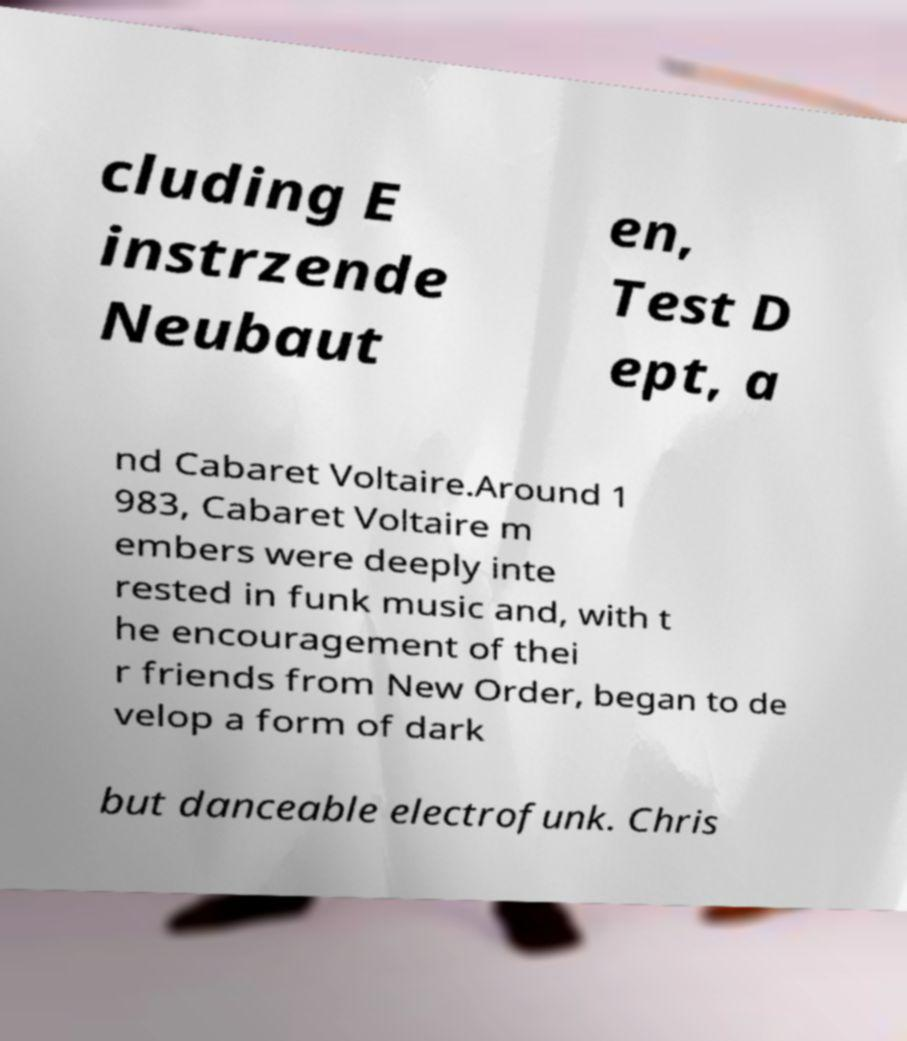Can you read and provide the text displayed in the image?This photo seems to have some interesting text. Can you extract and type it out for me? cluding E instrzende Neubaut en, Test D ept, a nd Cabaret Voltaire.Around 1 983, Cabaret Voltaire m embers were deeply inte rested in funk music and, with t he encouragement of thei r friends from New Order, began to de velop a form of dark but danceable electrofunk. Chris 